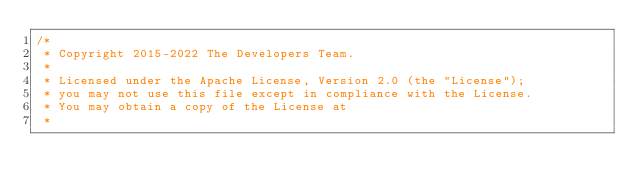Convert code to text. <code><loc_0><loc_0><loc_500><loc_500><_Scala_>/*
 * Copyright 2015-2022 The Developers Team.
 *
 * Licensed under the Apache License, Version 2.0 (the "License");
 * you may not use this file except in compliance with the License.
 * You may obtain a copy of the License at
 *</code> 